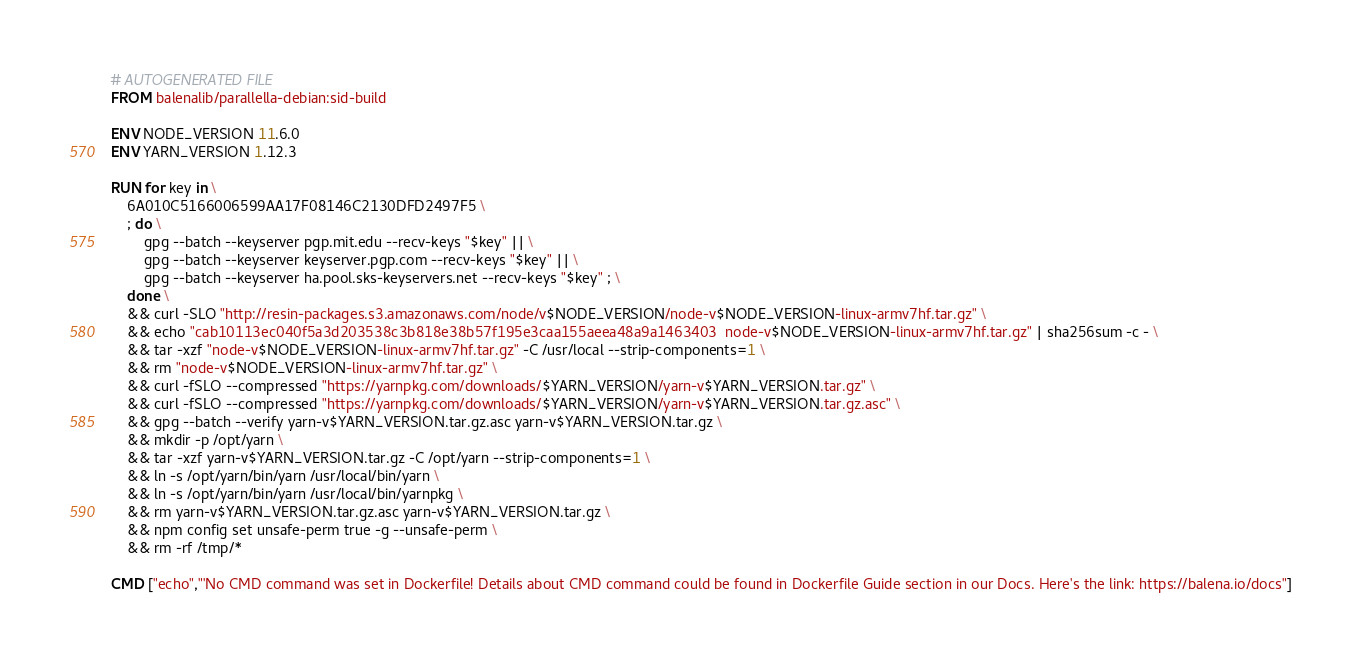<code> <loc_0><loc_0><loc_500><loc_500><_Dockerfile_># AUTOGENERATED FILE
FROM balenalib/parallella-debian:sid-build

ENV NODE_VERSION 11.6.0
ENV YARN_VERSION 1.12.3

RUN for key in \
	6A010C5166006599AA17F08146C2130DFD2497F5 \
	; do \
		gpg --batch --keyserver pgp.mit.edu --recv-keys "$key" || \
		gpg --batch --keyserver keyserver.pgp.com --recv-keys "$key" || \
		gpg --batch --keyserver ha.pool.sks-keyservers.net --recv-keys "$key" ; \
	done \
	&& curl -SLO "http://resin-packages.s3.amazonaws.com/node/v$NODE_VERSION/node-v$NODE_VERSION-linux-armv7hf.tar.gz" \
	&& echo "cab10113ec040f5a3d203538c3b818e38b57f195e3caa155aeea48a9a1463403  node-v$NODE_VERSION-linux-armv7hf.tar.gz" | sha256sum -c - \
	&& tar -xzf "node-v$NODE_VERSION-linux-armv7hf.tar.gz" -C /usr/local --strip-components=1 \
	&& rm "node-v$NODE_VERSION-linux-armv7hf.tar.gz" \
	&& curl -fSLO --compressed "https://yarnpkg.com/downloads/$YARN_VERSION/yarn-v$YARN_VERSION.tar.gz" \
	&& curl -fSLO --compressed "https://yarnpkg.com/downloads/$YARN_VERSION/yarn-v$YARN_VERSION.tar.gz.asc" \
	&& gpg --batch --verify yarn-v$YARN_VERSION.tar.gz.asc yarn-v$YARN_VERSION.tar.gz \
	&& mkdir -p /opt/yarn \
	&& tar -xzf yarn-v$YARN_VERSION.tar.gz -C /opt/yarn --strip-components=1 \
	&& ln -s /opt/yarn/bin/yarn /usr/local/bin/yarn \
	&& ln -s /opt/yarn/bin/yarn /usr/local/bin/yarnpkg \
	&& rm yarn-v$YARN_VERSION.tar.gz.asc yarn-v$YARN_VERSION.tar.gz \
	&& npm config set unsafe-perm true -g --unsafe-perm \
	&& rm -rf /tmp/*

CMD ["echo","'No CMD command was set in Dockerfile! Details about CMD command could be found in Dockerfile Guide section in our Docs. Here's the link: https://balena.io/docs"]</code> 